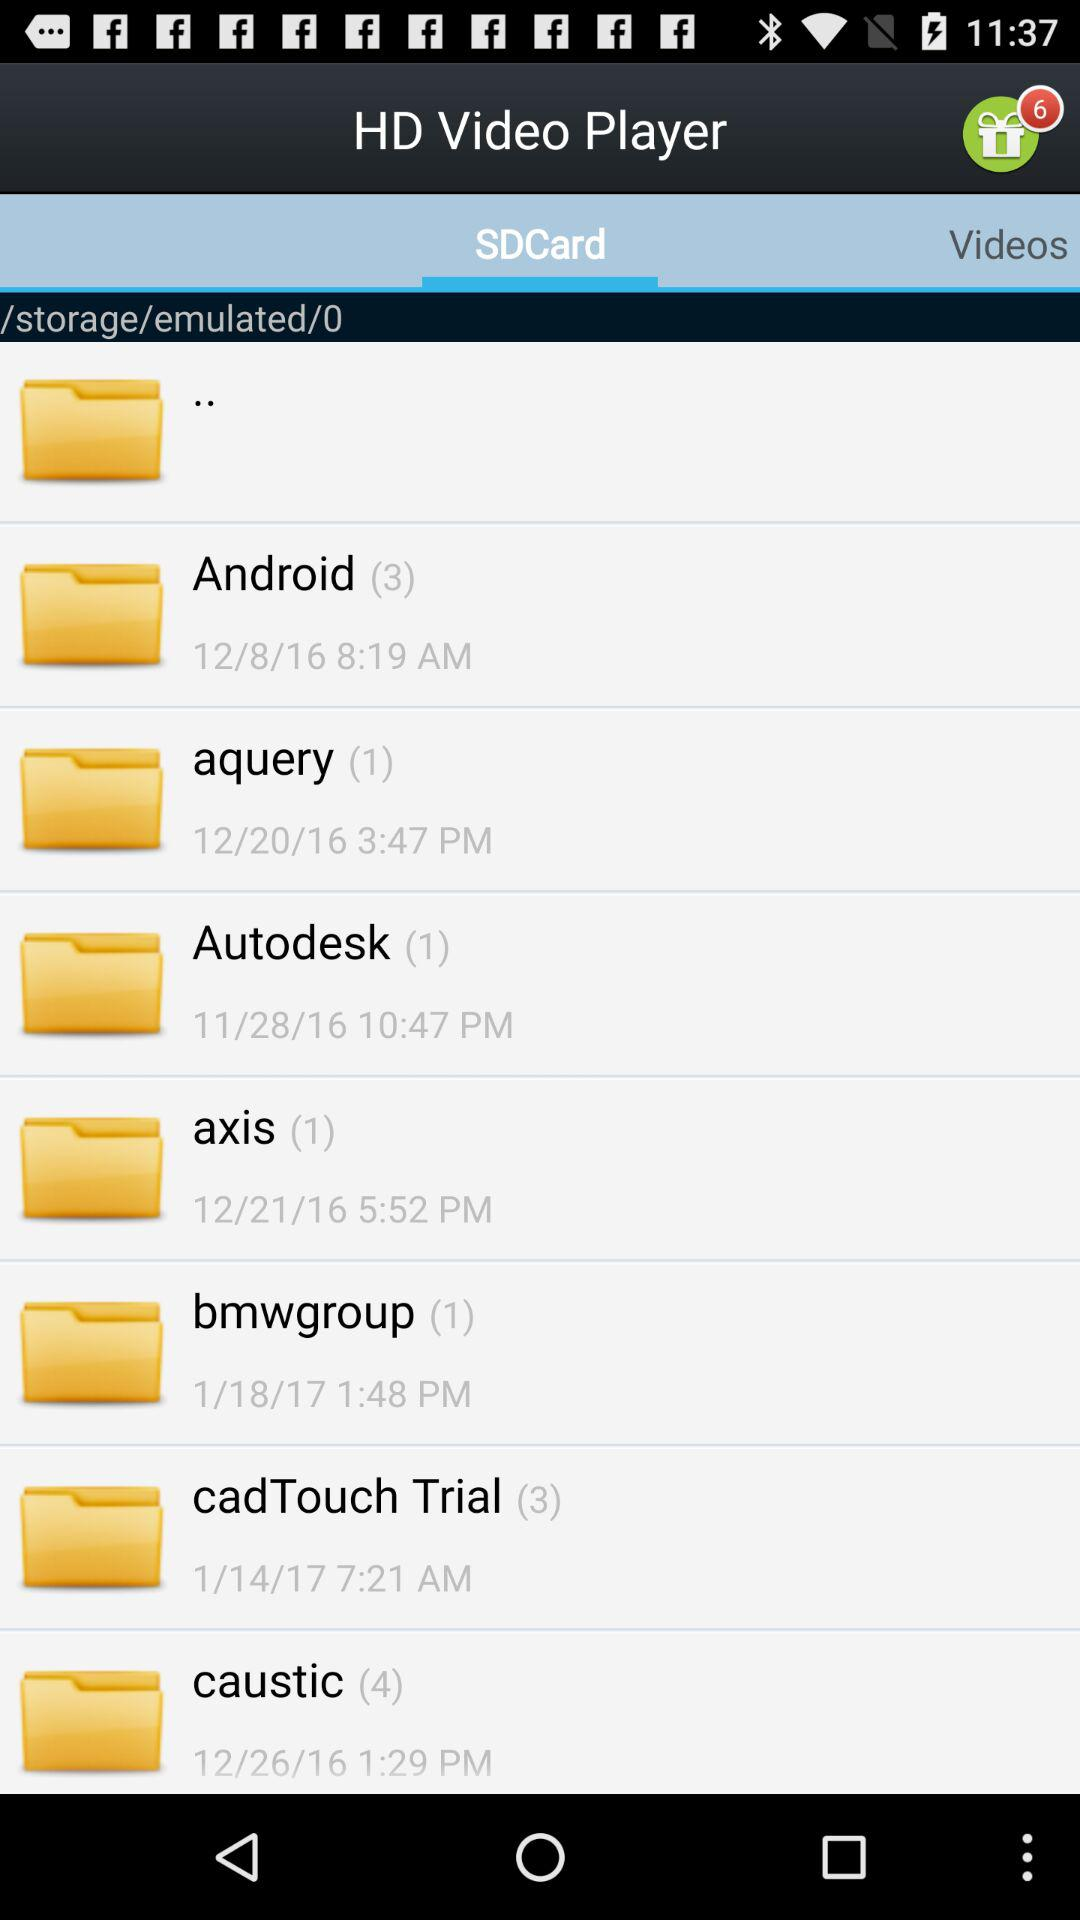Which tab is selected? The selected tab is "SDCard". 